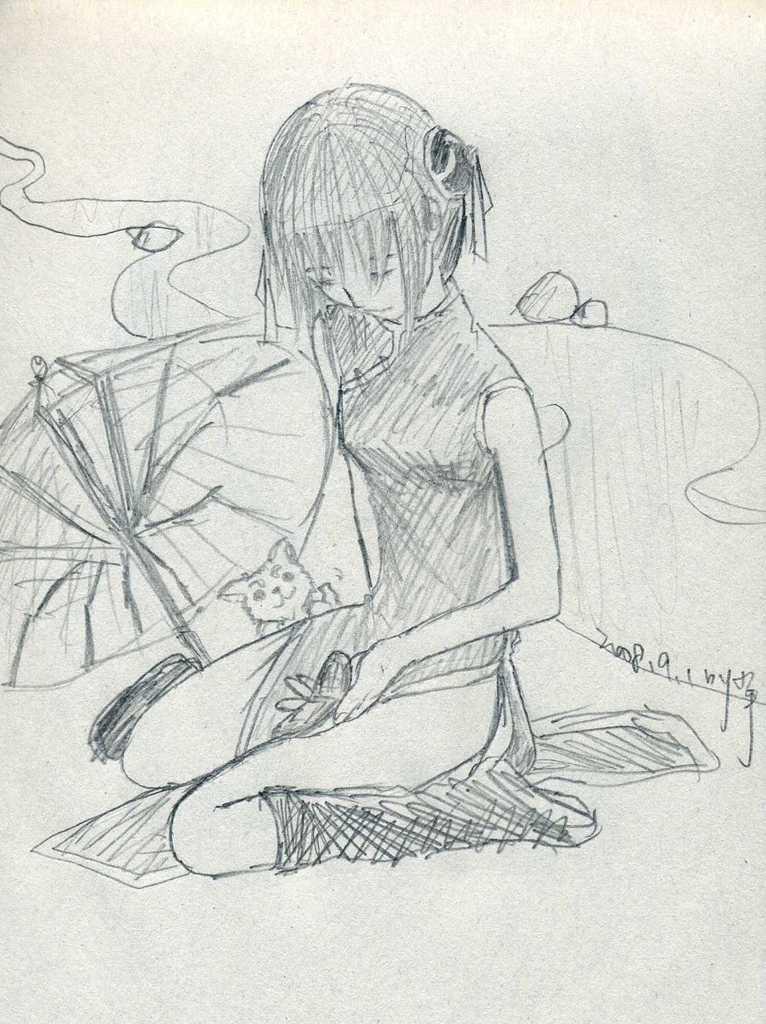How would you summarize this image in a sentence or two? In this picture we can see an art. 